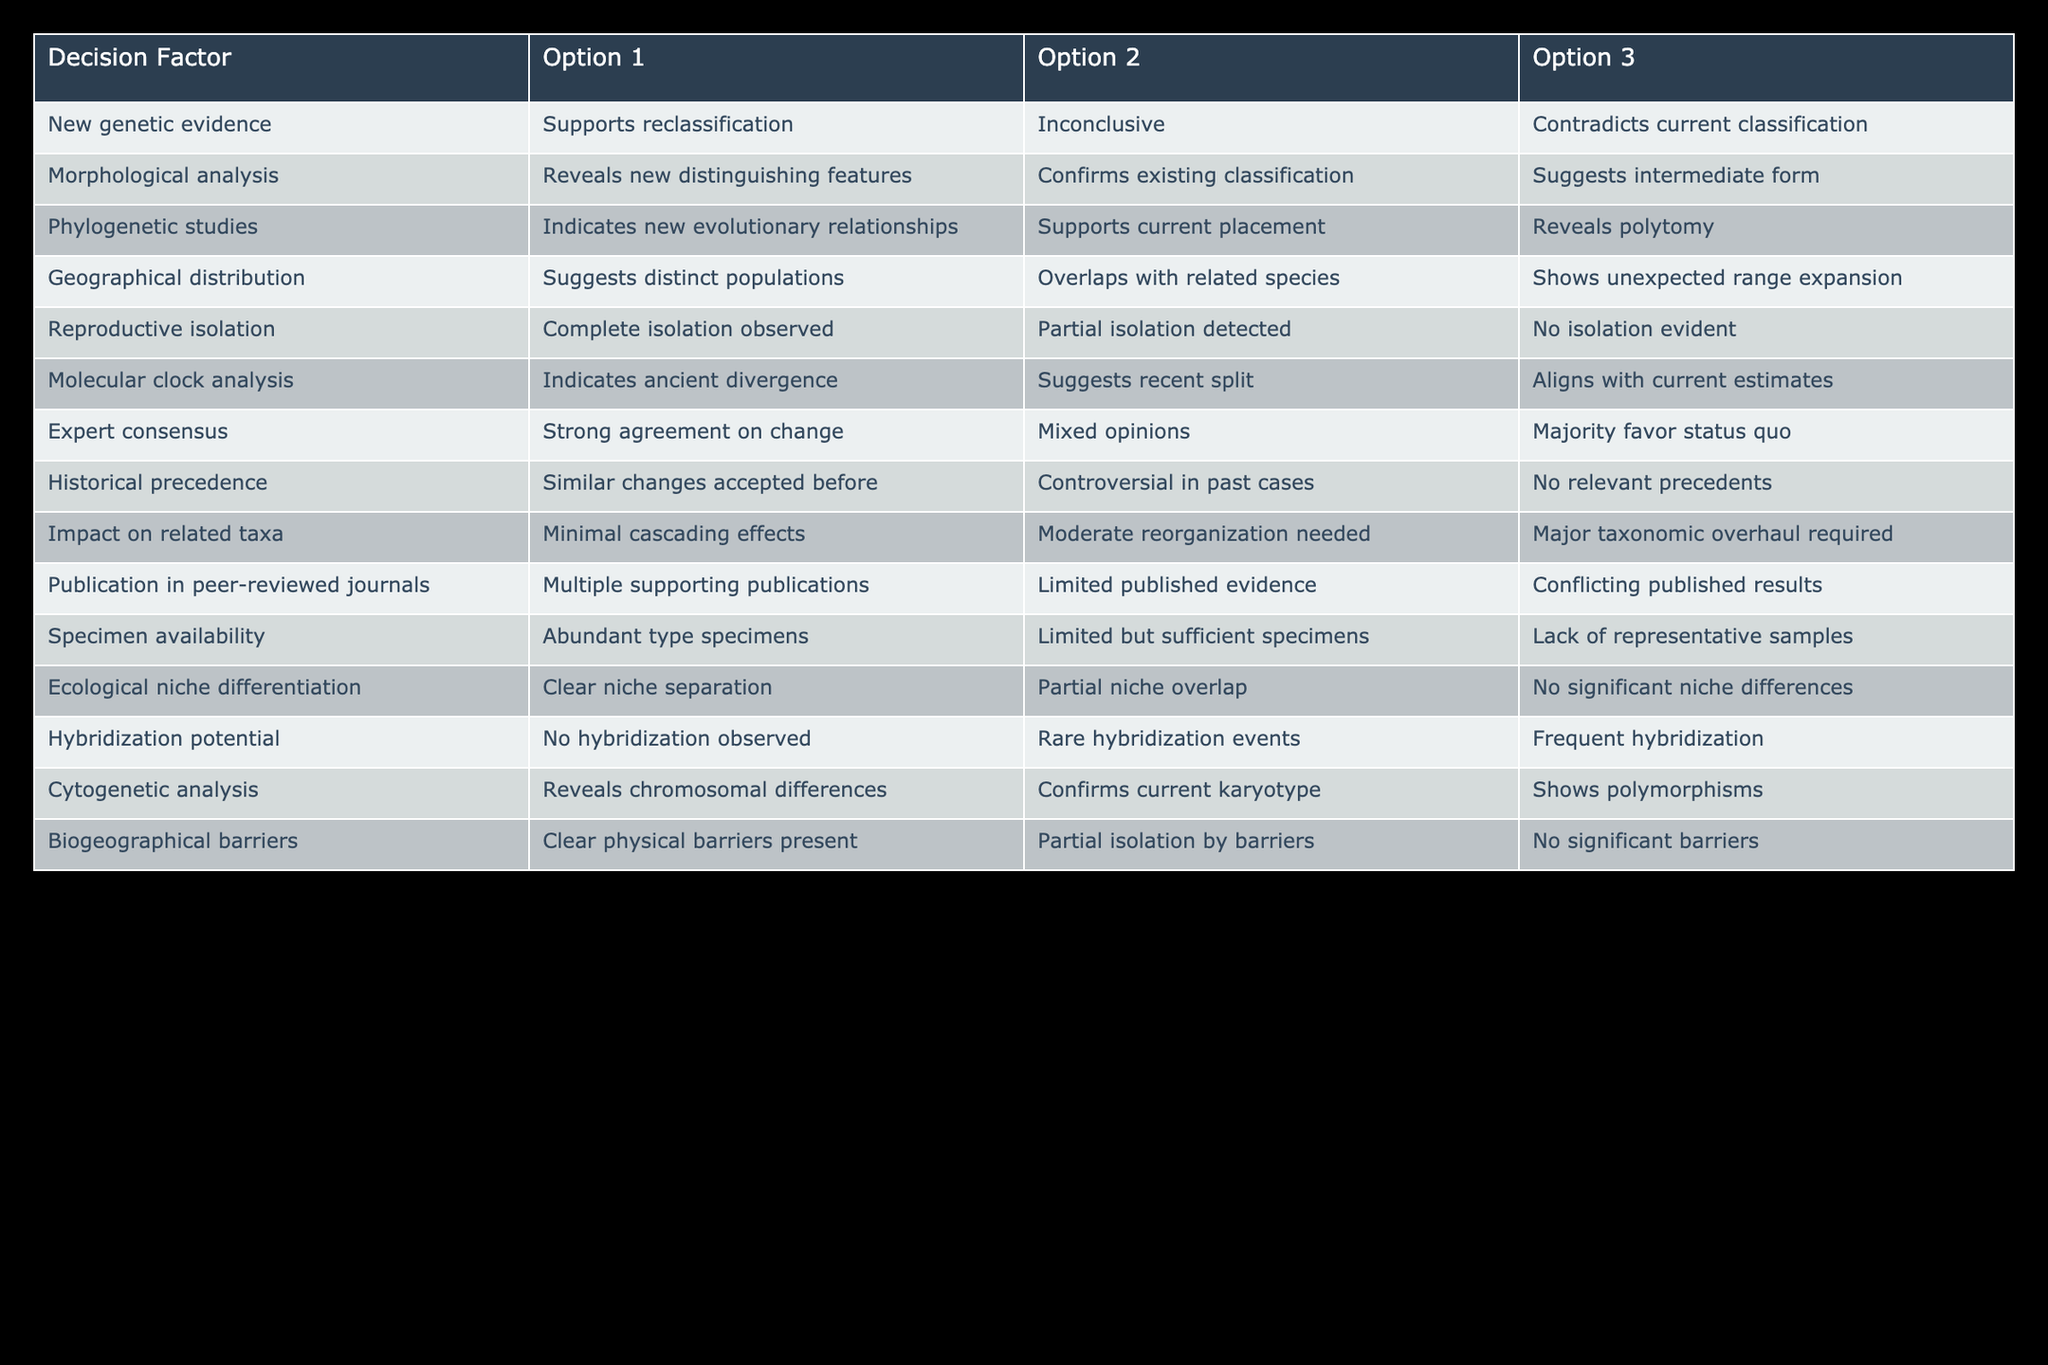What does the morphological analysis suggest? The second option under "Morphological analysis" shows "Confirms existing classification." This indicates that the morphological evidence doesn't support a change in nomenclature.
Answer: Confirms existing classification Is there a consensus among experts regarding the nomenclature change? In the "Expert consensus" row, the first option indicates "Strong agreement on change." This suggests a positive agreement among experts about updating the nomenclature.
Answer: Strong agreement on change Does new genetic evidence contradict the current classification? According to the first row, the third option states "Contradicts current classification." Thus, it confirms that there is evidence against the current taxonomic classification.
Answer: Yes What is the implication of historical precedence? The first option under "Historical precedence" indicates "Similar changes accepted before." This suggests that the current situation finds some parallel in past taxonomy updates, thus supporting a possible change.
Answer: Similar changes accepted before How many factors indicate a need for a major taxonomic overhaul? Looking through the "Impact on related taxa" row, the third option states "Major taxonomic overhaul required," indicating that this situation necessitates significant reorganization. Therefore, there is one factor that directly denotes the need for a major overhaul.
Answer: One factor What is the importance of molecular clock analysis in this decision process? The first option in "Molecular clock analysis" indicates "Indicates ancient divergence." This finding is crucial in determining the historical relationships between taxa, which can influence nomenclature decisions.
Answer: Indicates ancient divergence Are there any geographical barriers present according to the table? In the "Biogeographical barriers" row, "Clear physical barriers present" is mentioned in the first option, so yes, those barriers are established.
Answer: Yes What are the two main options regarding hybridization potential? The "Hybridization potential" row details three options: "No hybridization observed," "Rare hybridization events," and "Frequent hybridization." The first two options are relevant for assessing hybridization potential, so the two main ones would be: "No hybridization observed" and "Rare hybridization events."
Answer: No hybridization observed, Rare hybridization events What does the geographical distribution imply about the populations? The first option under "Geographical distribution" states "Suggests distinct populations." Therefore, the implication is that the populations are likely separate based on geographical evidence.
Answer: Suggests distinct populations 